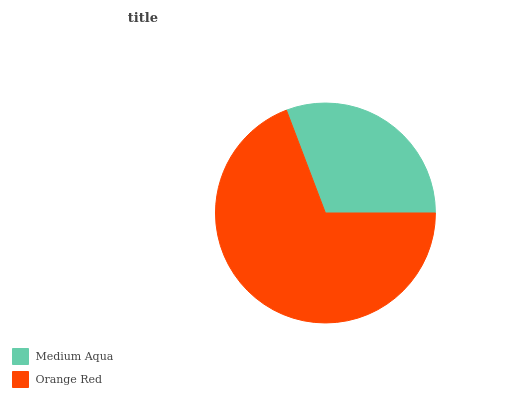Is Medium Aqua the minimum?
Answer yes or no. Yes. Is Orange Red the maximum?
Answer yes or no. Yes. Is Orange Red the minimum?
Answer yes or no. No. Is Orange Red greater than Medium Aqua?
Answer yes or no. Yes. Is Medium Aqua less than Orange Red?
Answer yes or no. Yes. Is Medium Aqua greater than Orange Red?
Answer yes or no. No. Is Orange Red less than Medium Aqua?
Answer yes or no. No. Is Orange Red the high median?
Answer yes or no. Yes. Is Medium Aqua the low median?
Answer yes or no. Yes. Is Medium Aqua the high median?
Answer yes or no. No. Is Orange Red the low median?
Answer yes or no. No. 